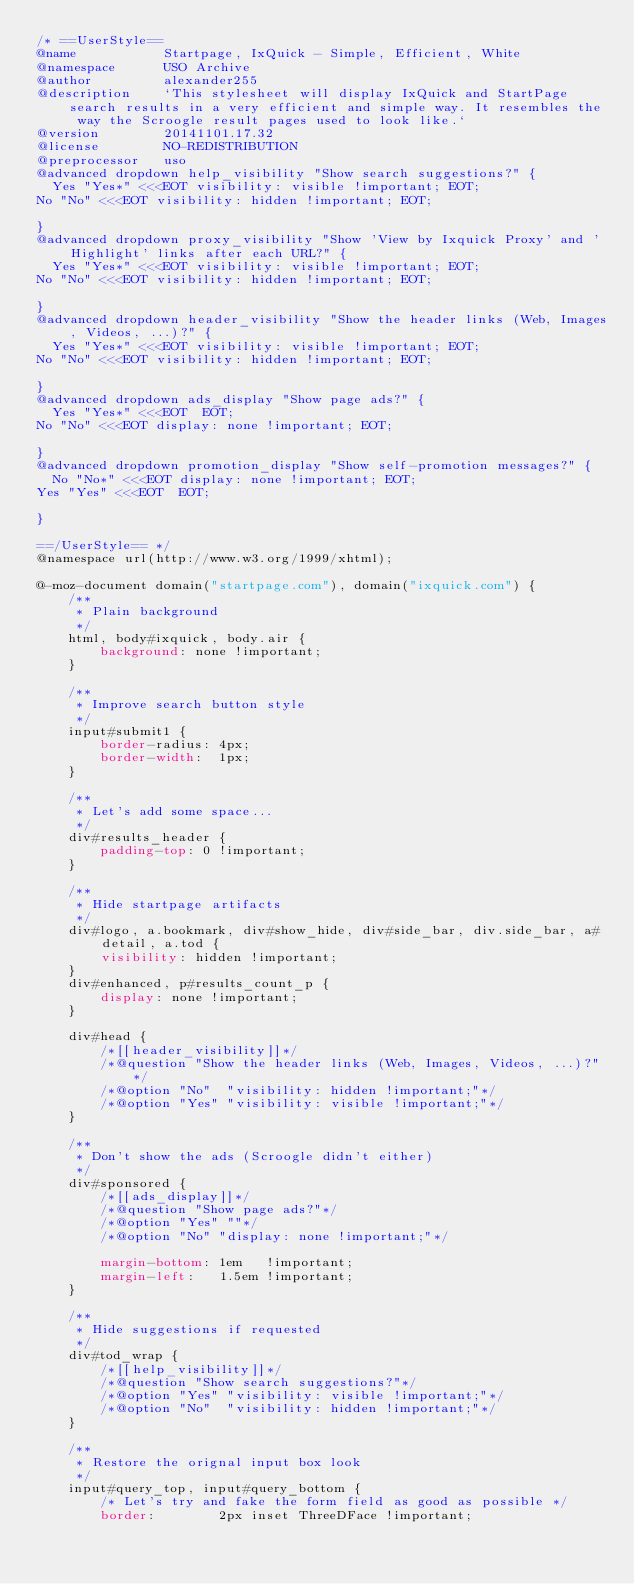<code> <loc_0><loc_0><loc_500><loc_500><_CSS_>/* ==UserStyle==
@name           Startpage, IxQuick - Simple, Efficient, White
@namespace      USO Archive
@author         alexander255
@description    `This stylesheet will display IxQuick and StartPage search results in a very efficient and simple way. It resembles the way the Scroogle result pages used to look like.`
@version        20141101.17.32
@license        NO-REDISTRIBUTION
@preprocessor   uso
@advanced dropdown help_visibility "Show search suggestions?" {
	Yes "Yes*" <<<EOT visibility: visible !important; EOT;
No "No" <<<EOT visibility: hidden !important; EOT;

}
@advanced dropdown proxy_visibility "Show 'View by Ixquick Proxy' and 'Highlight' links after each URL?" {
	Yes "Yes*" <<<EOT visibility: visible !important; EOT;
No "No" <<<EOT visibility: hidden !important; EOT;

}
@advanced dropdown header_visibility "Show the header links (Web, Images, Videos, ...)?" {
	Yes "Yes*" <<<EOT visibility: visible !important; EOT;
No "No" <<<EOT visibility: hidden !important; EOT;

}
@advanced dropdown ads_display "Show page ads?" {
	Yes "Yes*" <<<EOT  EOT;
No "No" <<<EOT display: none !important; EOT;

}
@advanced dropdown promotion_display "Show self-promotion messages?" {
	No "No*" <<<EOT display: none !important; EOT;
Yes "Yes" <<<EOT  EOT;

}

==/UserStyle== */
@namespace url(http://www.w3.org/1999/xhtml);

@-moz-document domain("startpage.com"), domain("ixquick.com") {
    /**
     * Plain background
     */
    html, body#ixquick, body.air {
        background: none !important;
    }

    /**
     * Improve search button style
     */
    input#submit1 {
        border-radius: 4px;
        border-width:  1px;
    }
    
    /**
     * Let's add some space...
     */
    div#results_header {
        padding-top: 0 !important;
    }
    
    /**
     * Hide startpage artifacts
     */
    div#logo, a.bookmark, div#show_hide, div#side_bar, div.side_bar, a#detail, a.tod {
        visibility: hidden !important;
    }
    div#enhanced, p#results_count_p {
        display: none !important;
    }
    
    div#head {
        /*[[header_visibility]]*/
        /*@question "Show the header links (Web, Images, Videos, ...)?"*/
        /*@option "No"  "visibility: hidden !important;"*/
        /*@option "Yes" "visibility: visible !important;"*/
    }
    
    /**
     * Don't show the ads (Scroogle didn't either)
     */
    div#sponsored {
        /*[[ads_display]]*/
        /*@question "Show page ads?"*/
        /*@option "Yes" ""*/
        /*@option "No" "display: none !important;"*/
        
        margin-bottom: 1em   !important;
        margin-left:   1.5em !important;
    }
    
    /**
     * Hide suggestions if requested
     */
    div#tod_wrap {
        /*[[help_visibility]]*/
        /*@question "Show search suggestions?"*/
        /*@option "Yes" "visibility: visible !important;"*/
        /*@option "No"  "visibility: hidden !important;"*/
    }
    
    /**
     * Restore the orignal input box look
     */
    input#query_top, input#query_bottom {
        /* Let's try and fake the form field as good as possible */
        border:        2px inset ThreeDFace !important;</code> 